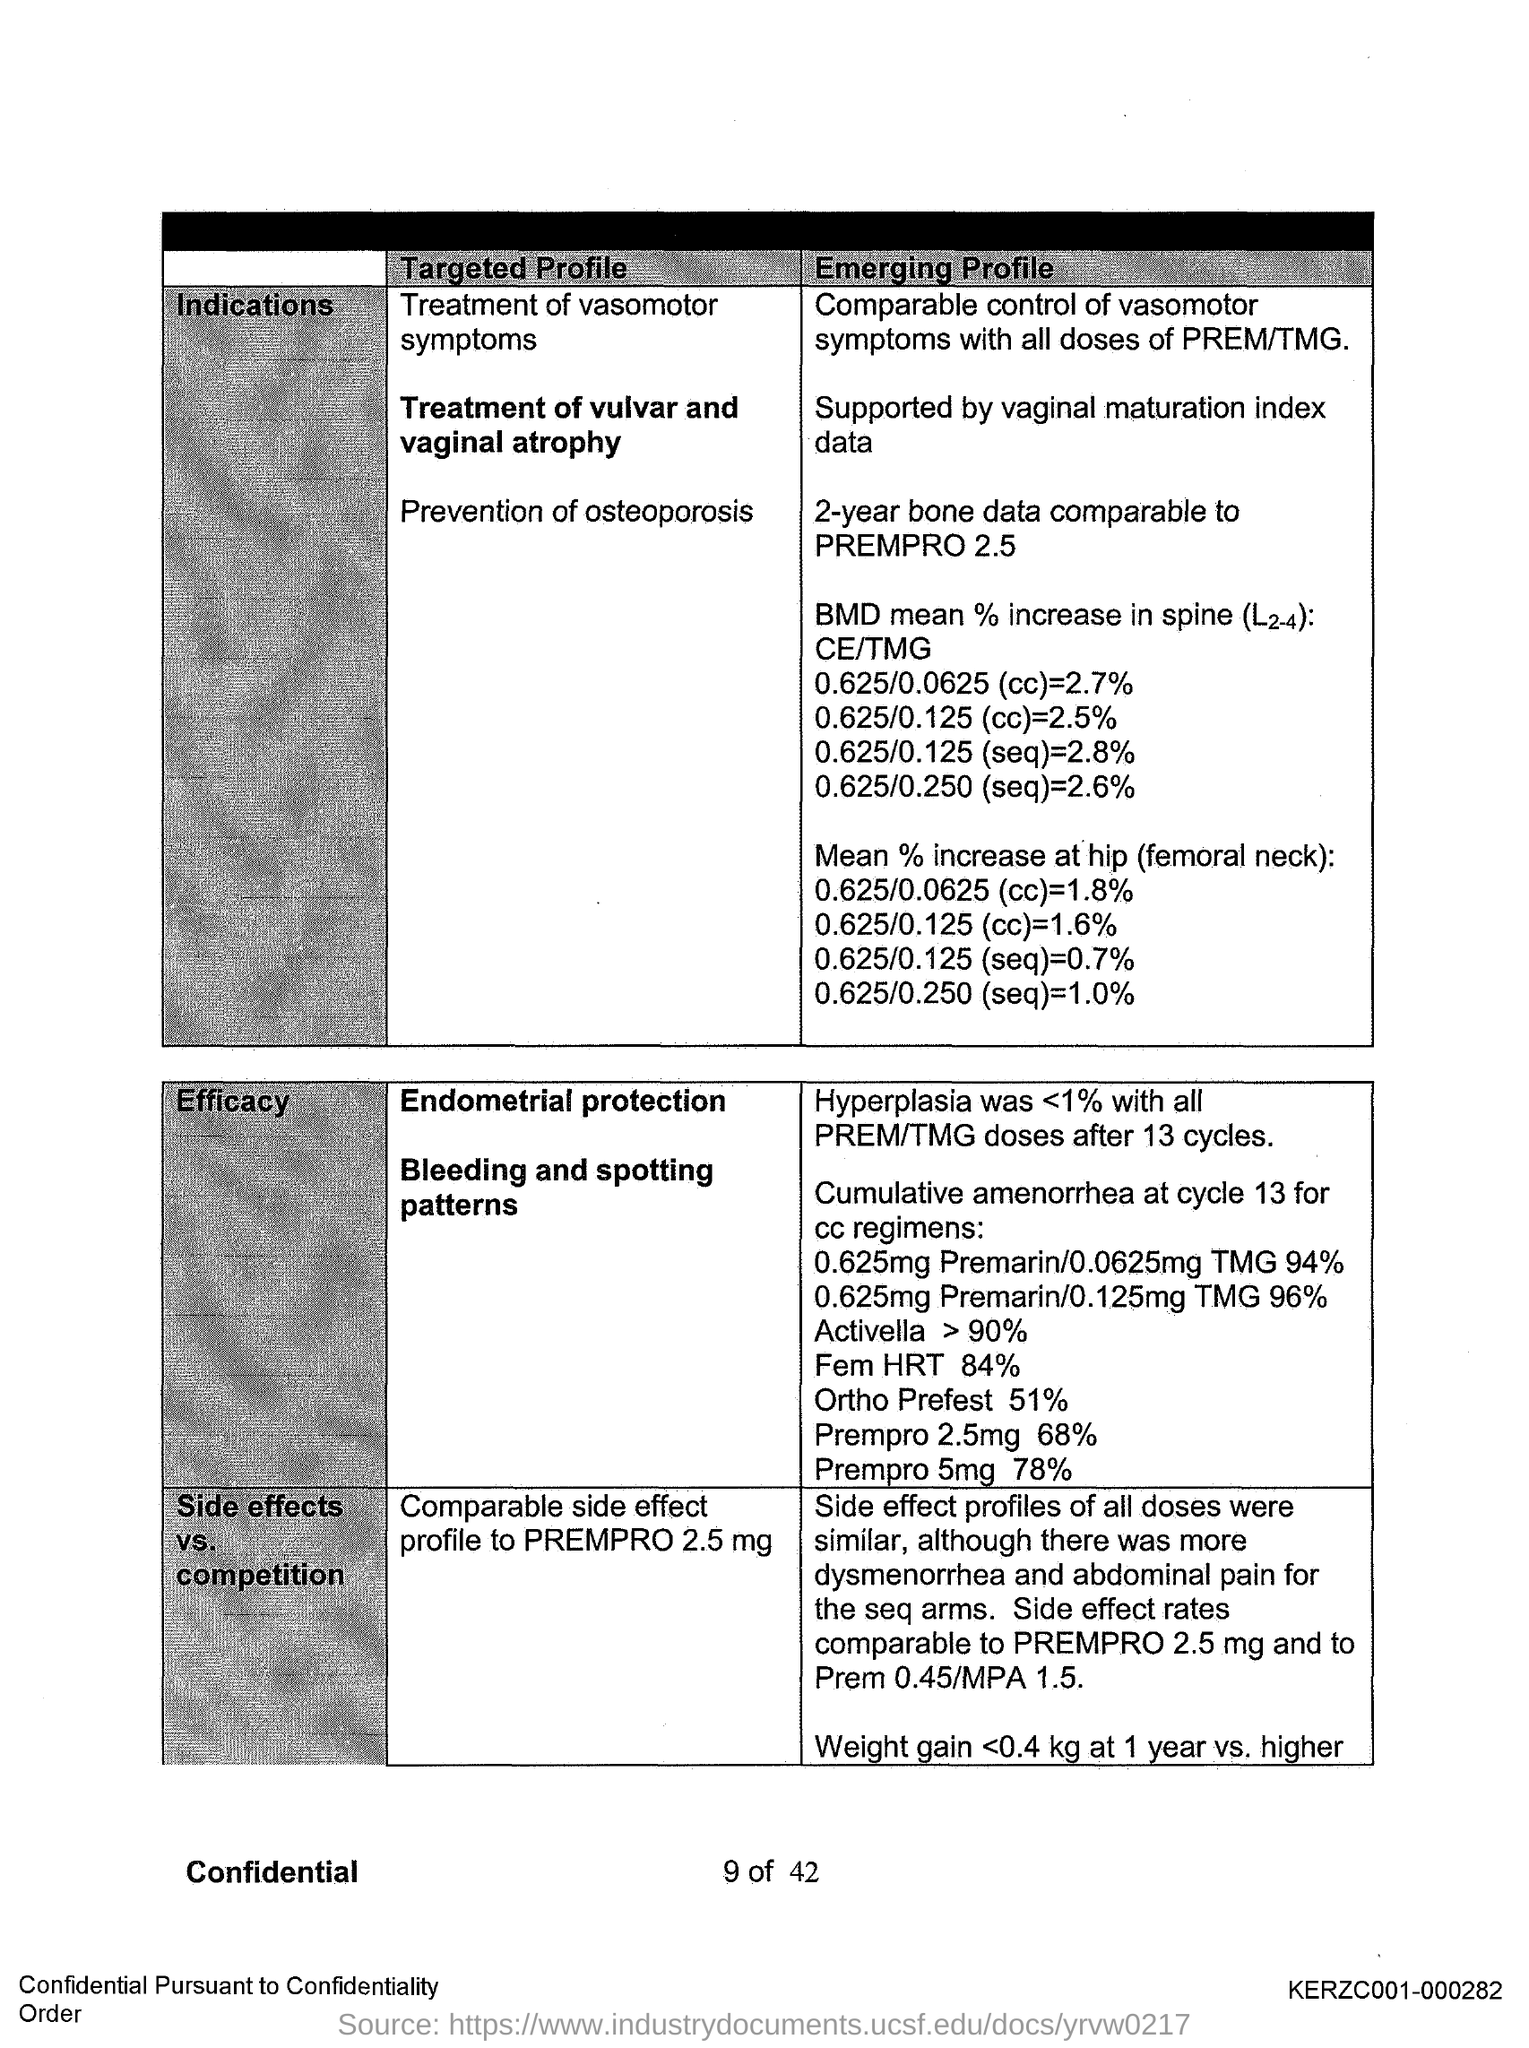What is the "Mean % increase at hip (femoral neck):0.625/0.250 (seq)"? The mean percentage increase at the hip (femoral neck) for a sequential dosage of 0.625/0.250 is reported to be an increase of 1.0%. 